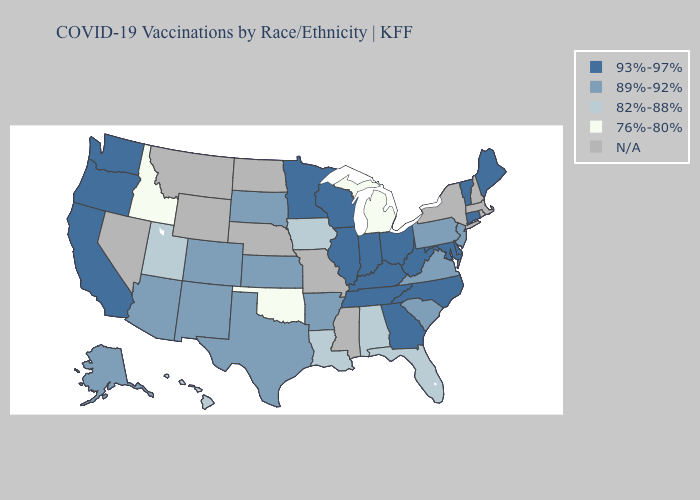Does North Carolina have the lowest value in the USA?
Quick response, please. No. Among the states that border South Dakota , which have the lowest value?
Give a very brief answer. Iowa. Does West Virginia have the highest value in the USA?
Give a very brief answer. Yes. How many symbols are there in the legend?
Keep it brief. 5. Name the states that have a value in the range 76%-80%?
Write a very short answer. Idaho, Michigan, Oklahoma. Name the states that have a value in the range 76%-80%?
Answer briefly. Idaho, Michigan, Oklahoma. What is the lowest value in the West?
Short answer required. 76%-80%. Among the states that border Missouri , does Kansas have the lowest value?
Keep it brief. No. Which states hav the highest value in the MidWest?
Concise answer only. Illinois, Indiana, Minnesota, Ohio, Wisconsin. What is the highest value in the West ?
Short answer required. 93%-97%. Does Maine have the highest value in the USA?
Be succinct. Yes. Name the states that have a value in the range 93%-97%?
Concise answer only. California, Connecticut, Delaware, Georgia, Illinois, Indiana, Kentucky, Maine, Maryland, Minnesota, North Carolina, Ohio, Oregon, Tennessee, Vermont, Washington, West Virginia, Wisconsin. What is the value of Kentucky?
Be succinct. 93%-97%. What is the value of South Carolina?
Be succinct. 89%-92%. 